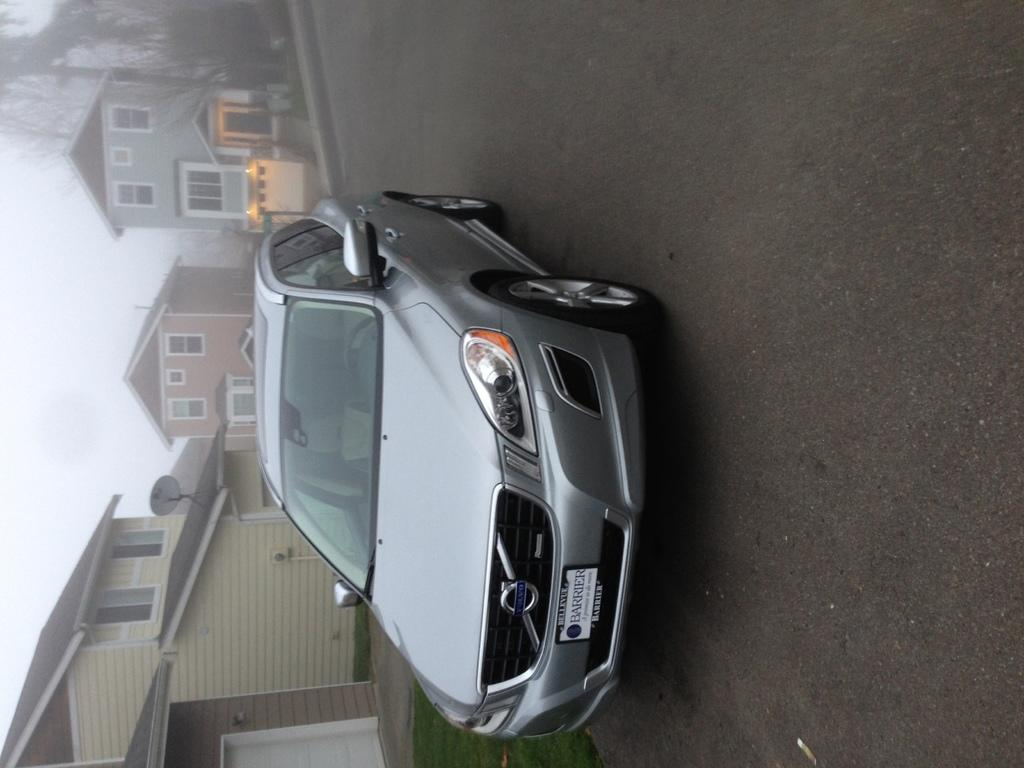What is the main subject of the image? There is a car on the road in the image. What can be seen in the background of the image? There is grass, buildings, an antenna, lights, trees, and the sky visible in the background of the image. What type of toothpaste is being discussed in the image? There is no discussion or toothpaste present in the image. What class is the car in the image a part of? The image does not provide information about the car's class or any classification system. 